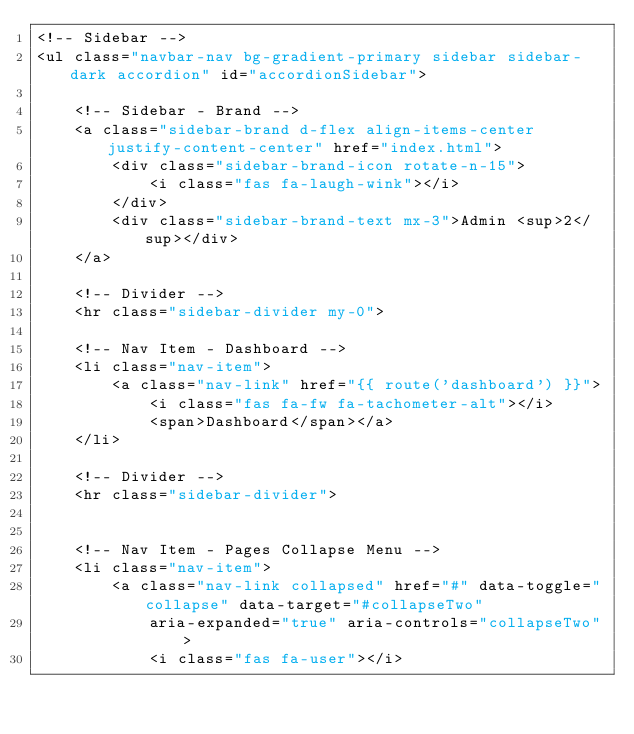<code> <loc_0><loc_0><loc_500><loc_500><_PHP_><!-- Sidebar -->
<ul class="navbar-nav bg-gradient-primary sidebar sidebar-dark accordion" id="accordionSidebar">

    <!-- Sidebar - Brand -->
    <a class="sidebar-brand d-flex align-items-center justify-content-center" href="index.html">
        <div class="sidebar-brand-icon rotate-n-15">
            <i class="fas fa-laugh-wink"></i>
        </div>
        <div class="sidebar-brand-text mx-3">Admin <sup>2</sup></div>
    </a>

    <!-- Divider -->
    <hr class="sidebar-divider my-0">

    <!-- Nav Item - Dashboard -->
    <li class="nav-item">
        <a class="nav-link" href="{{ route('dashboard') }}">
            <i class="fas fa-fw fa-tachometer-alt"></i>
            <span>Dashboard</span></a>
    </li>

    <!-- Divider -->
    <hr class="sidebar-divider">


    <!-- Nav Item - Pages Collapse Menu -->
    <li class="nav-item">
        <a class="nav-link collapsed" href="#" data-toggle="collapse" data-target="#collapseTwo"
            aria-expanded="true" aria-controls="collapseTwo">
            <i class="fas fa-user"></i></code> 